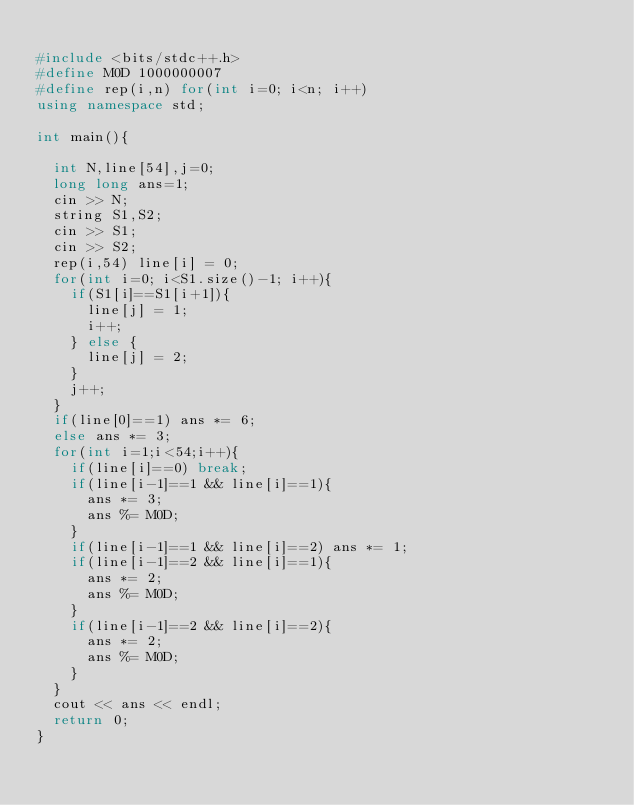<code> <loc_0><loc_0><loc_500><loc_500><_C++_>
#include <bits/stdc++.h>
#define M0D 1000000007
#define rep(i,n) for(int i=0; i<n; i++)
using namespace std;

int main(){

  int N,line[54],j=0;
  long long ans=1;
  cin >> N;
  string S1,S2;
  cin >> S1;
  cin >> S2;
  rep(i,54) line[i] = 0;
  for(int i=0; i<S1.size()-1; i++){
    if(S1[i]==S1[i+1]){
      line[j] = 1;
      i++;
    } else {
      line[j] = 2;
    }
    j++;
  }
  if(line[0]==1) ans *= 6;
  else ans *= 3;
  for(int i=1;i<54;i++){
    if(line[i]==0) break;
    if(line[i-1]==1 && line[i]==1){
      ans *= 3;
      ans %= M0D;
    }
    if(line[i-1]==1 && line[i]==2) ans *= 1;
    if(line[i-1]==2 && line[i]==1){
      ans *= 2;
      ans %= M0D;
    }
    if(line[i-1]==2 && line[i]==2){
      ans *= 2;
      ans %= M0D;
    }
  }
  cout << ans << endl;
  return 0;
}
</code> 